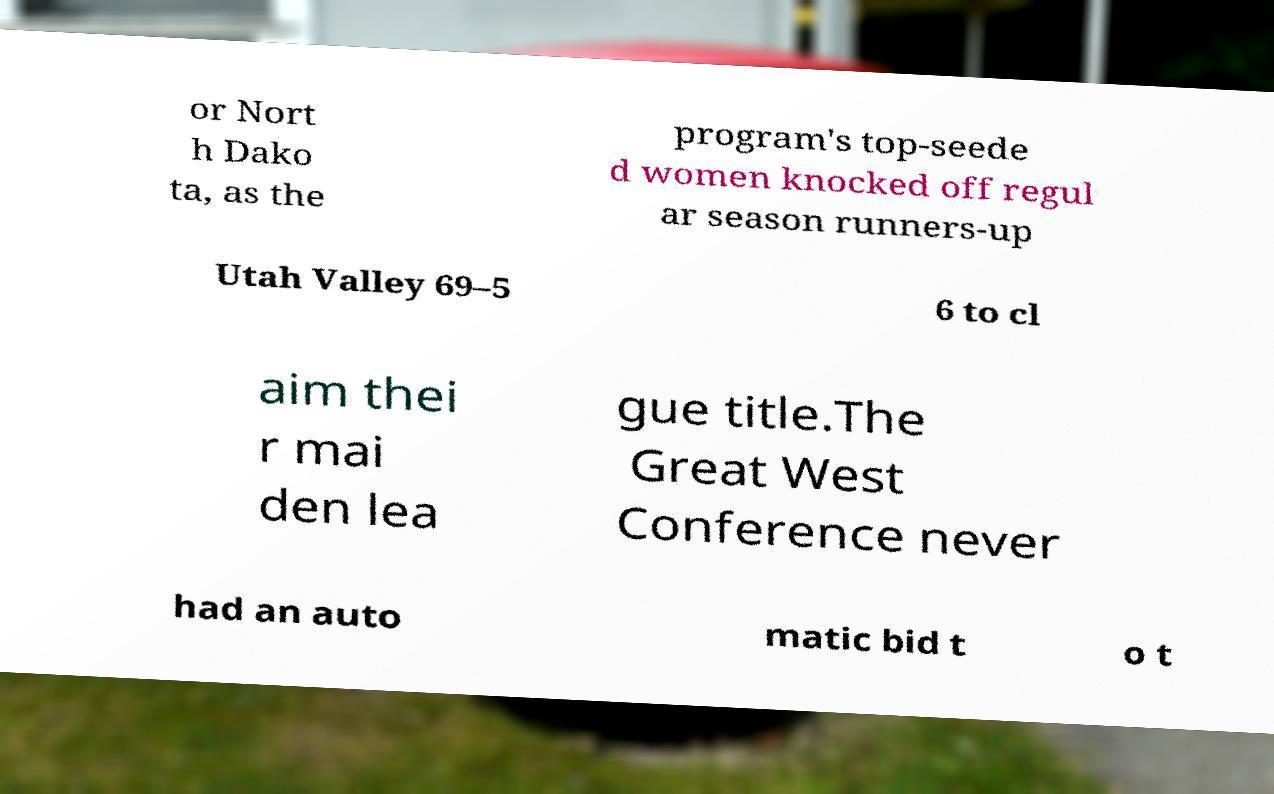Could you assist in decoding the text presented in this image and type it out clearly? or Nort h Dako ta, as the program's top-seede d women knocked off regul ar season runners-up Utah Valley 69–5 6 to cl aim thei r mai den lea gue title.The Great West Conference never had an auto matic bid t o t 